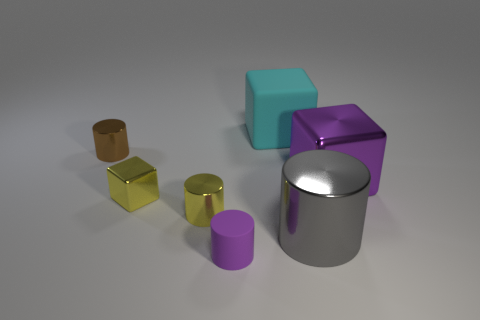Subtract all purple cylinders. How many cylinders are left? 3 Subtract all yellow cylinders. How many cylinders are left? 3 Add 2 tiny yellow cylinders. How many objects exist? 9 Subtract all blue cylinders. Subtract all blue blocks. How many cylinders are left? 4 Subtract all cylinders. How many objects are left? 3 Subtract 1 gray cylinders. How many objects are left? 6 Subtract all small green metallic cubes. Subtract all big cyan rubber objects. How many objects are left? 6 Add 1 brown things. How many brown things are left? 2 Add 4 large gray metal blocks. How many large gray metal blocks exist? 4 